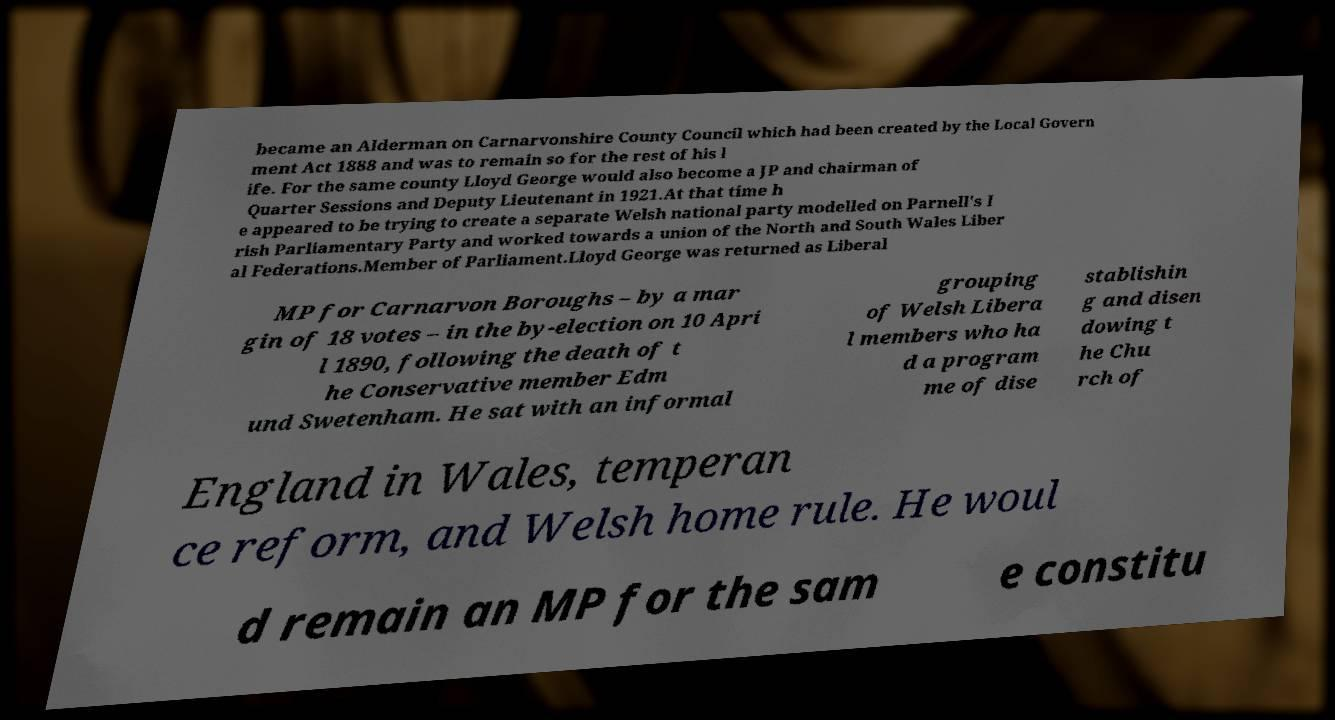Can you accurately transcribe the text from the provided image for me? became an Alderman on Carnarvonshire County Council which had been created by the Local Govern ment Act 1888 and was to remain so for the rest of his l ife. For the same county Lloyd George would also become a JP and chairman of Quarter Sessions and Deputy Lieutenant in 1921.At that time h e appeared to be trying to create a separate Welsh national party modelled on Parnell's I rish Parliamentary Party and worked towards a union of the North and South Wales Liber al Federations.Member of Parliament.Lloyd George was returned as Liberal MP for Carnarvon Boroughs – by a mar gin of 18 votes – in the by-election on 10 Apri l 1890, following the death of t he Conservative member Edm und Swetenham. He sat with an informal grouping of Welsh Libera l members who ha d a program me of dise stablishin g and disen dowing t he Chu rch of England in Wales, temperan ce reform, and Welsh home rule. He woul d remain an MP for the sam e constitu 